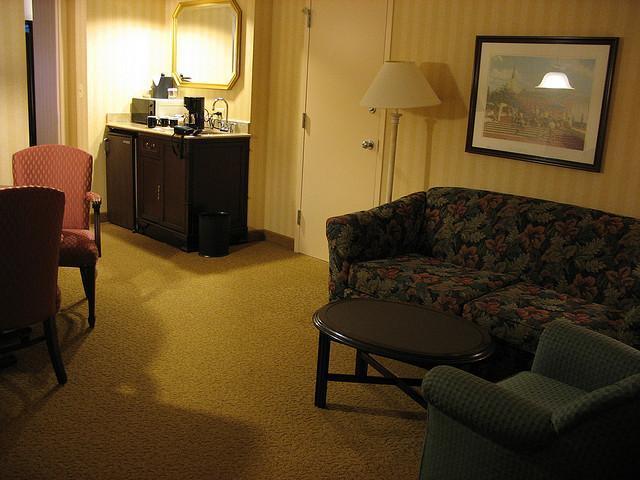How many chairs can be seen?
Give a very brief answer. 3. 